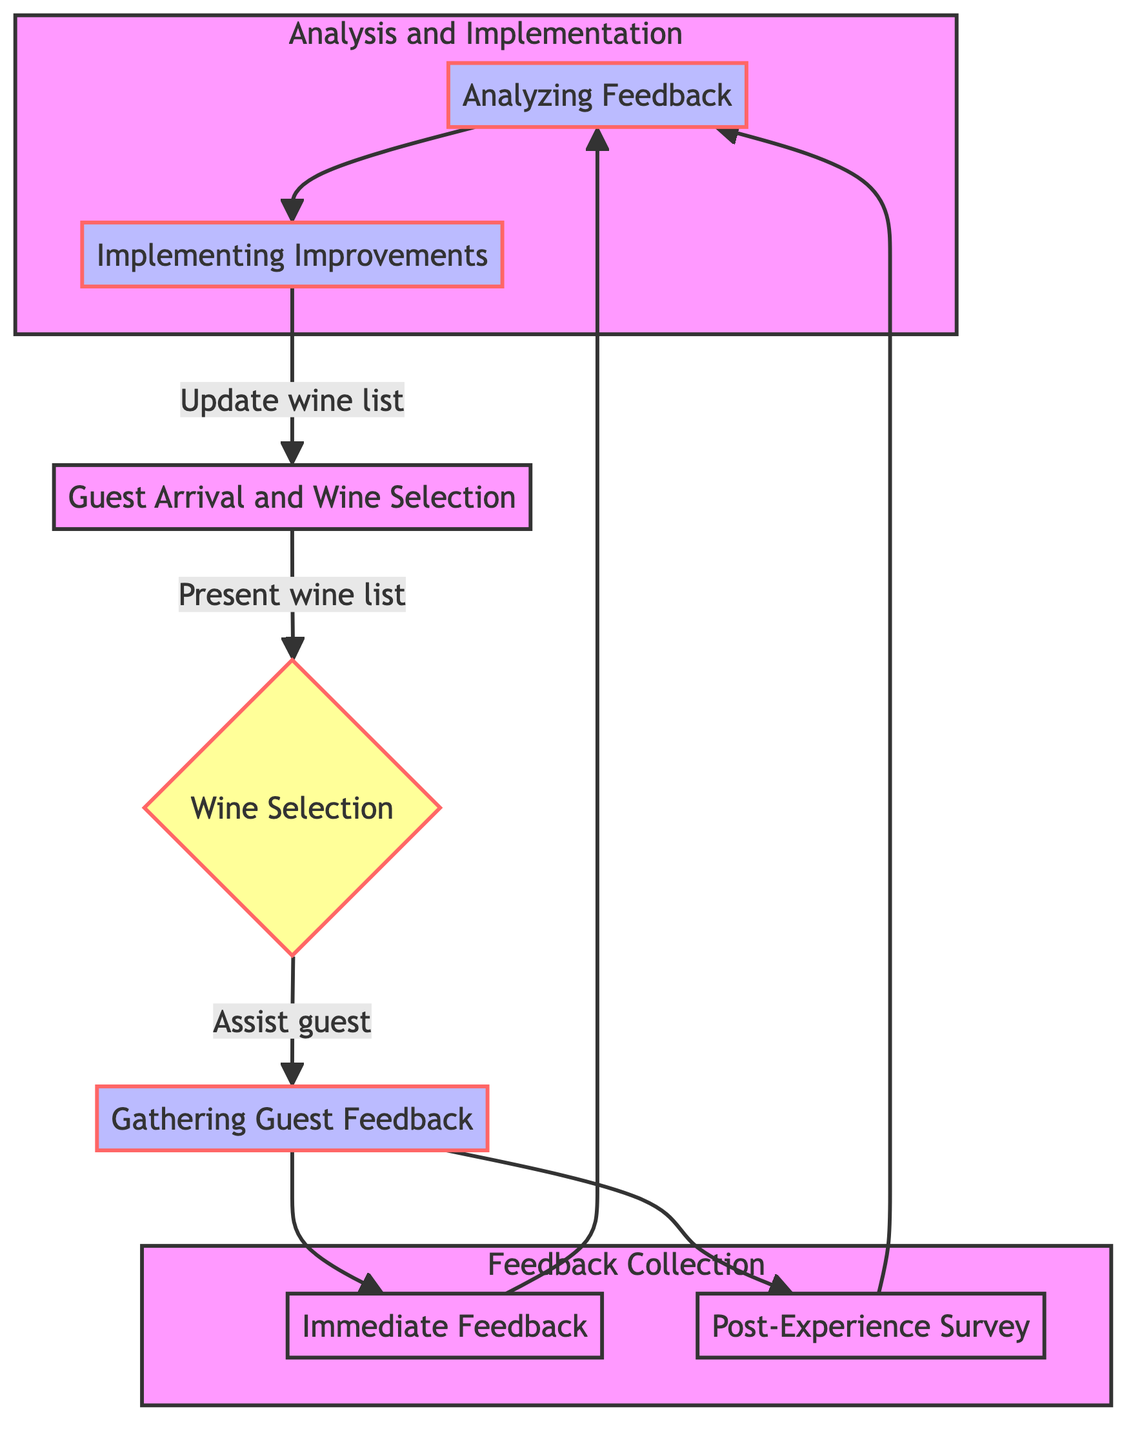What is the first step in the pathway? The diagram indicates that the first step is "Guest Arrival and Wine Selection." This is displayed as the initial node at the start of the flow.
Answer: Guest Arrival and Wine Selection How many methods are used to gather feedback? The diagram shows two methods for gathering feedback: Immediate Feedback and Post-Experience Survey. This can be counted by identifying the number of nodes under the feedback collection section.
Answer: 2 What action follows the "Gathering Guest Feedback"? In the diagram, after "Gathering Guest Feedback," the next action indicated is "Analyzing Feedback." This follows from the arrows representing the flow of the pathway.
Answer: Analyzing Feedback Which tools are used for Immediate Feedback? The tools listed for Immediate Feedback in the pathway are "Waiter request verbal feedback after the first sip" and "Quick smiley-faced feedback cards provided." Identifying these from the feedback collection section answers this question.
Answer: Waiter request verbal feedback after the first sip, Quick smiley-faced feedback cards provided What improvement is implemented based on guest preferences? The diagram shows that one of the actions for "Implementing Improvements" is "Update wine list based on guest preferences." This is found by looking at the actions listed under the implementation phase.
Answer: Update wine list based on guest preferences How does the feedback collection process connect to analyzing feedback? The connection is established by the arrows in the diagram. After collecting feedback (Immediate Feedback and Post-Experience Survey), the next node indicates the flow continues to "Analyzing Feedback." This is a sequential relationship depicted in the diagram.
Answer: Through arrows leading to Analyzing Feedback What type of feedback is gathered immediately? The type of feedback gathered immediately is termed "Immediate Feedback" in the diagram. This is a direct label found in the feedback collection section.
Answer: Immediate Feedback What is the last action taken in the pathway? The last action indicated in the pathway is "Implementing Improvements," which then leads back to the first step "Guest Arrival and Wine Selection," suggesting a continuous cycle. This is seen at the end of the diagram flow.
Answer: Implementing Improvements 